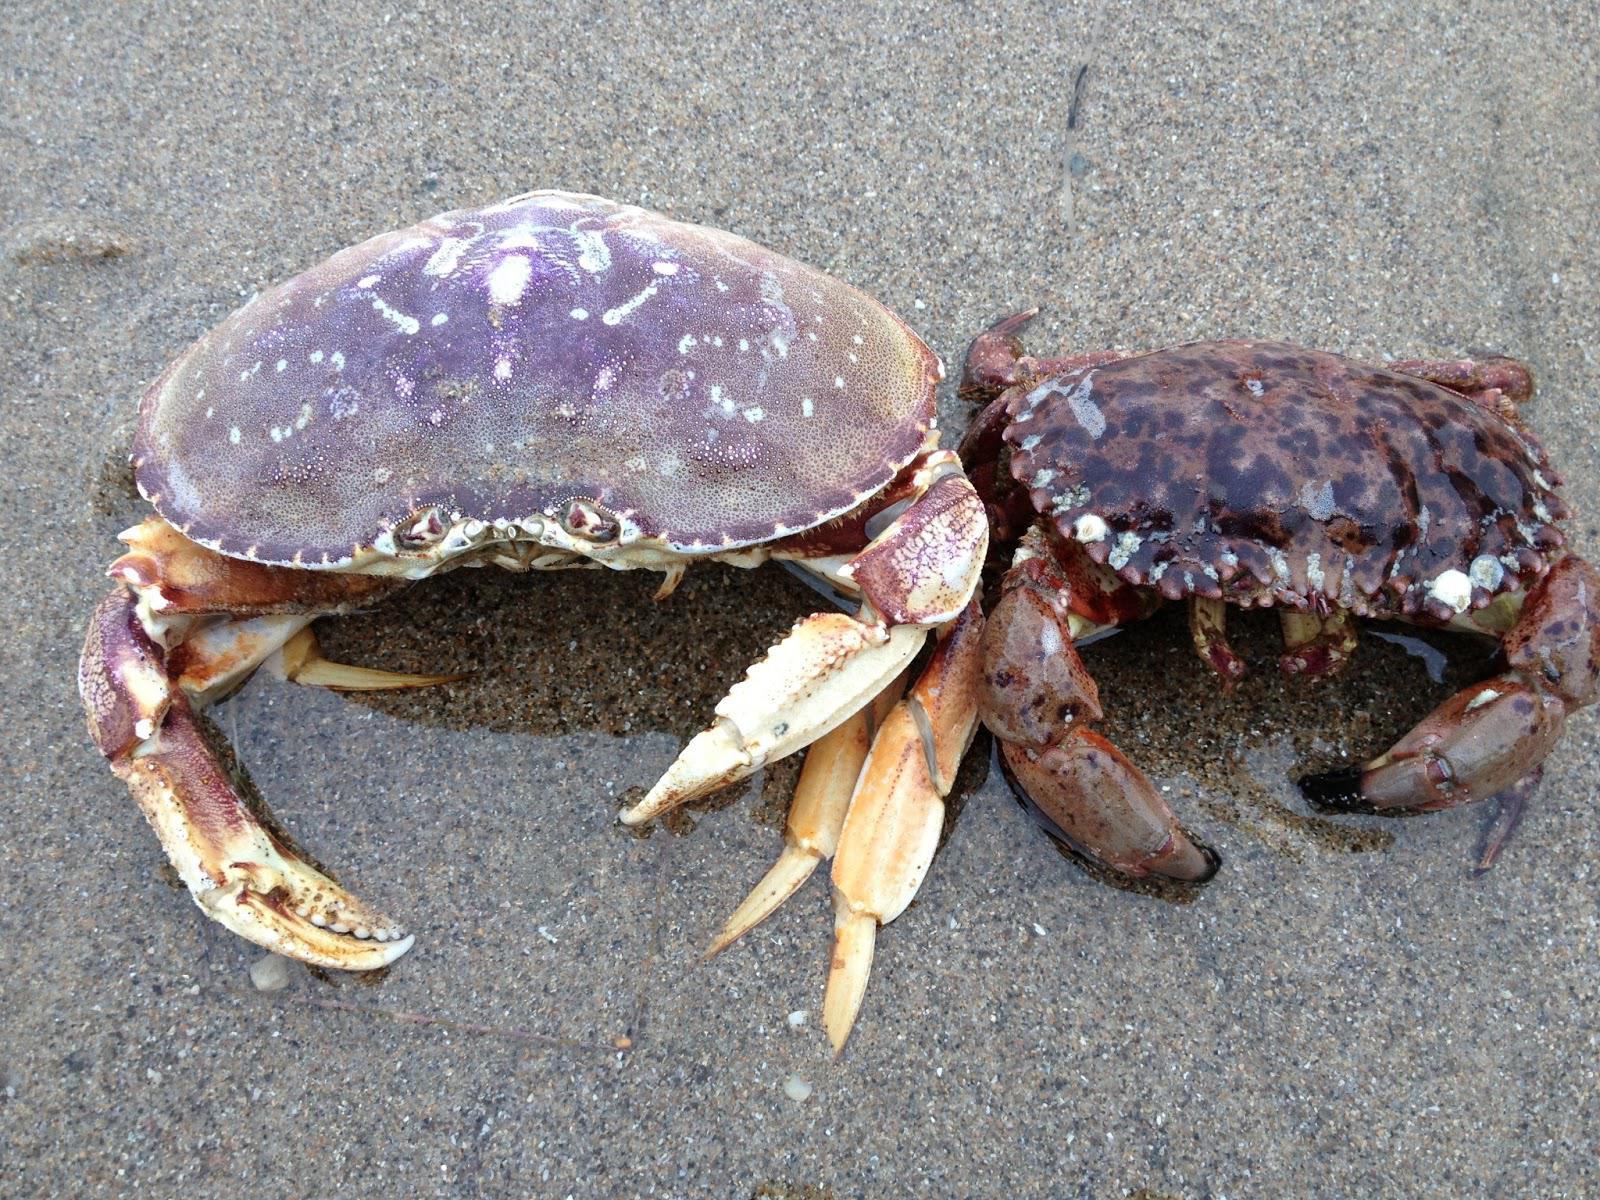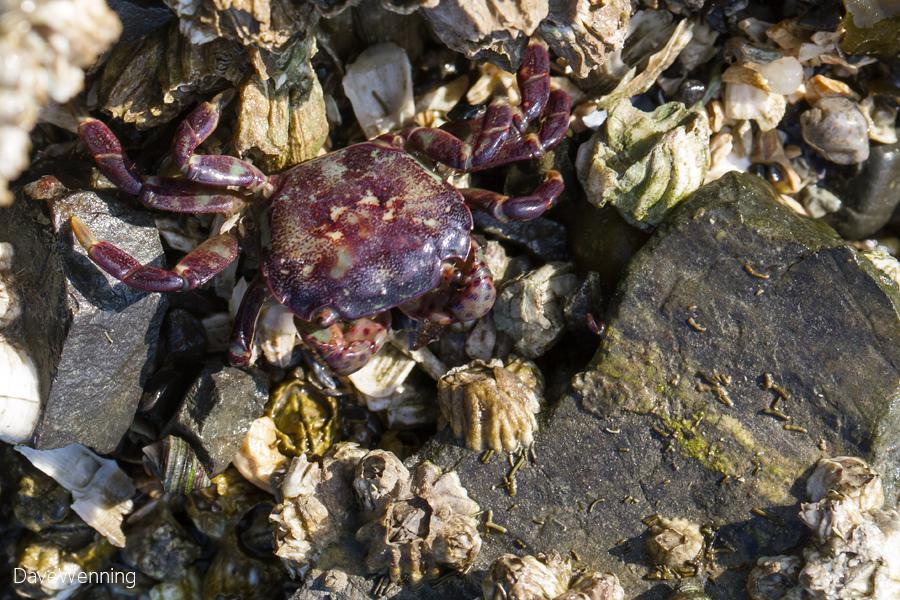The first image is the image on the left, the second image is the image on the right. Given the left and right images, does the statement "There are at least three crabs in the image pair." hold true? Answer yes or no. Yes. The first image is the image on the left, the second image is the image on the right. Assess this claim about the two images: "There are at least two crabs with blue and red colors on it.". Correct or not? Answer yes or no. Yes. 